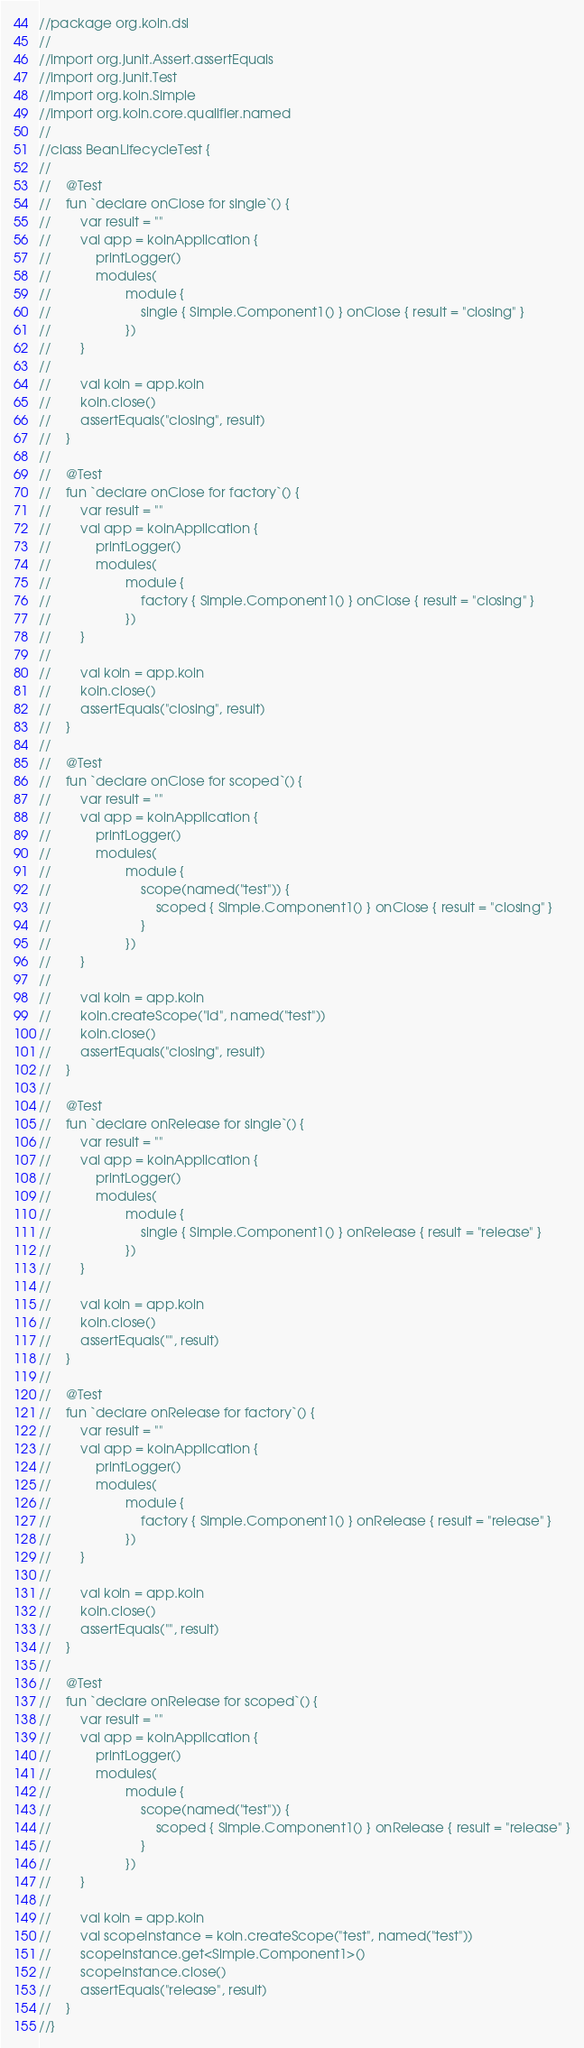<code> <loc_0><loc_0><loc_500><loc_500><_Kotlin_>//package org.koin.dsl
//
//import org.junit.Assert.assertEquals
//import org.junit.Test
//import org.koin.Simple
//import org.koin.core.qualifier.named
//
//class BeanLifecycleTest {
//
//    @Test
//    fun `declare onClose for single`() {
//        var result = ""
//        val app = koinApplication {
//            printLogger()
//            modules(
//                    module {
//                        single { Simple.Component1() } onClose { result = "closing" }
//                    })
//        }
//
//        val koin = app.koin
//        koin.close()
//        assertEquals("closing", result)
//    }
//
//    @Test
//    fun `declare onClose for factory`() {
//        var result = ""
//        val app = koinApplication {
//            printLogger()
//            modules(
//                    module {
//                        factory { Simple.Component1() } onClose { result = "closing" }
//                    })
//        }
//
//        val koin = app.koin
//        koin.close()
//        assertEquals("closing", result)
//    }
//
//    @Test
//    fun `declare onClose for scoped`() {
//        var result = ""
//        val app = koinApplication {
//            printLogger()
//            modules(
//                    module {
//                        scope(named("test")) {
//                            scoped { Simple.Component1() } onClose { result = "closing" }
//                        }
//                    })
//        }
//
//        val koin = app.koin
//        koin.createScope("id", named("test"))
//        koin.close()
//        assertEquals("closing", result)
//    }
//
//    @Test
//    fun `declare onRelease for single`() {
//        var result = ""
//        val app = koinApplication {
//            printLogger()
//            modules(
//                    module {
//                        single { Simple.Component1() } onRelease { result = "release" }
//                    })
//        }
//
//        val koin = app.koin
//        koin.close()
//        assertEquals("", result)
//    }
//
//    @Test
//    fun `declare onRelease for factory`() {
//        var result = ""
//        val app = koinApplication {
//            printLogger()
//            modules(
//                    module {
//                        factory { Simple.Component1() } onRelease { result = "release" }
//                    })
//        }
//
//        val koin = app.koin
//        koin.close()
//        assertEquals("", result)
//    }
//
//    @Test
//    fun `declare onRelease for scoped`() {
//        var result = ""
//        val app = koinApplication {
//            printLogger()
//            modules(
//                    module {
//                        scope(named("test")) {
//                            scoped { Simple.Component1() } onRelease { result = "release" }
//                        }
//                    })
//        }
//
//        val koin = app.koin
//        val scopeInstance = koin.createScope("test", named("test"))
//        scopeInstance.get<Simple.Component1>()
//        scopeInstance.close()
//        assertEquals("release", result)
//    }
//}</code> 